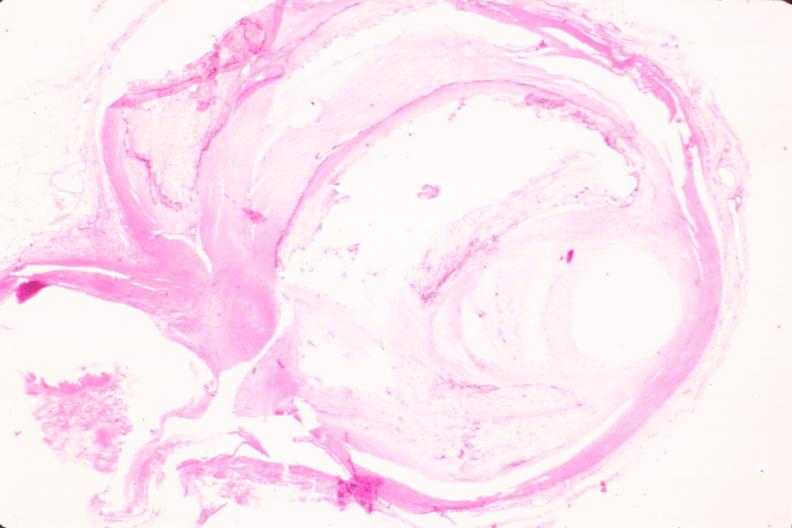s cardiovascular present?
Answer the question using a single word or phrase. Yes 